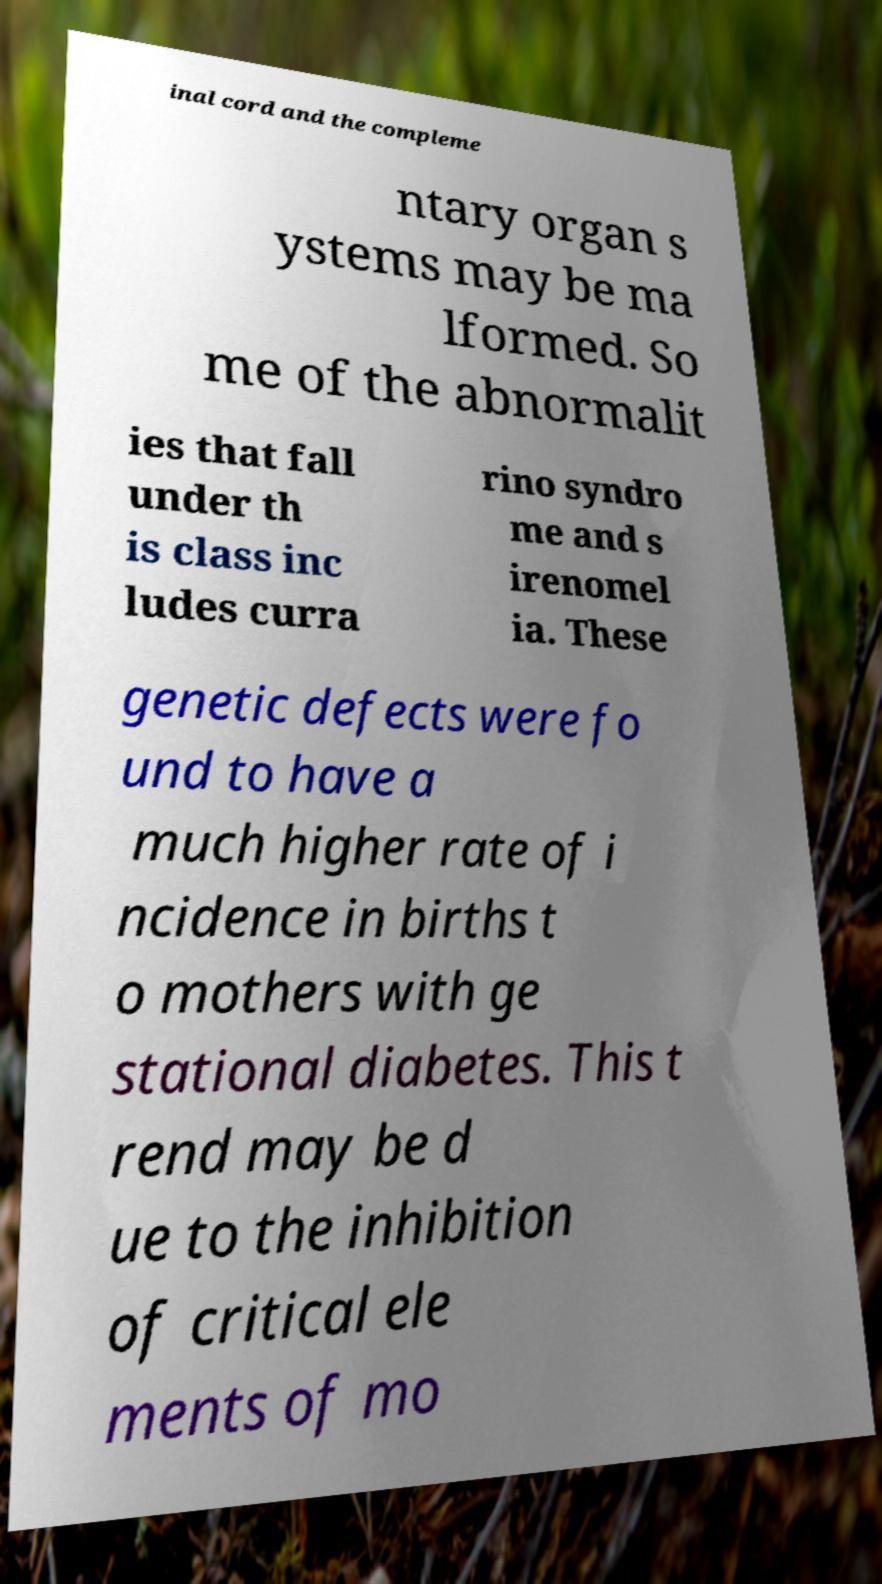Could you extract and type out the text from this image? inal cord and the compleme ntary organ s ystems may be ma lformed. So me of the abnormalit ies that fall under th is class inc ludes curra rino syndro me and s irenomel ia. These genetic defects were fo und to have a much higher rate of i ncidence in births t o mothers with ge stational diabetes. This t rend may be d ue to the inhibition of critical ele ments of mo 